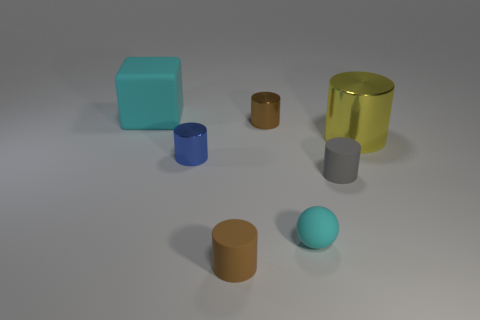There is a small cylinder behind the blue metal cylinder; what material is it?
Provide a succinct answer. Metal. Are there an equal number of tiny blue metallic objects that are behind the big yellow shiny thing and tiny rubber cylinders?
Your answer should be very brief. No. Does the small blue thing have the same shape as the large cyan rubber object?
Keep it short and to the point. No. Is there any other thing that has the same color as the sphere?
Ensure brevity in your answer.  Yes. What shape is the thing that is both in front of the brown metallic thing and on the left side of the brown rubber cylinder?
Your answer should be very brief. Cylinder. Are there an equal number of tiny cyan balls behind the small gray object and large metal cylinders that are left of the large rubber block?
Your answer should be very brief. Yes. What number of cylinders are tiny red metal objects or tiny things?
Provide a short and direct response. 4. What number of tiny cyan things have the same material as the tiny blue cylinder?
Ensure brevity in your answer.  0. What shape is the thing that is the same color as the tiny matte ball?
Provide a succinct answer. Cube. The object that is on the right side of the brown metal cylinder and left of the gray cylinder is made of what material?
Your answer should be very brief. Rubber. 